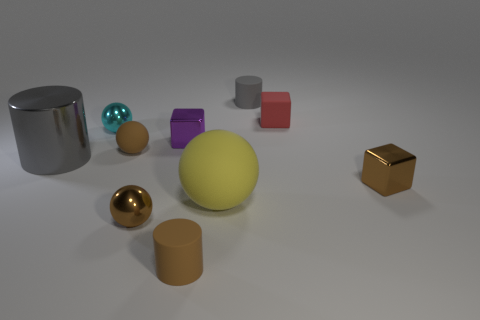Subtract all green cylinders. How many brown spheres are left? 2 Subtract all small purple shiny cubes. How many cubes are left? 2 Subtract all cyan spheres. How many spheres are left? 3 Subtract all blocks. How many objects are left? 7 Subtract all blue spheres. Subtract all brown blocks. How many spheres are left? 4 Subtract all tiny yellow matte cylinders. Subtract all red things. How many objects are left? 9 Add 1 small purple metal blocks. How many small purple metal blocks are left? 2 Add 4 small gray shiny cubes. How many small gray shiny cubes exist? 4 Subtract 1 red cubes. How many objects are left? 9 